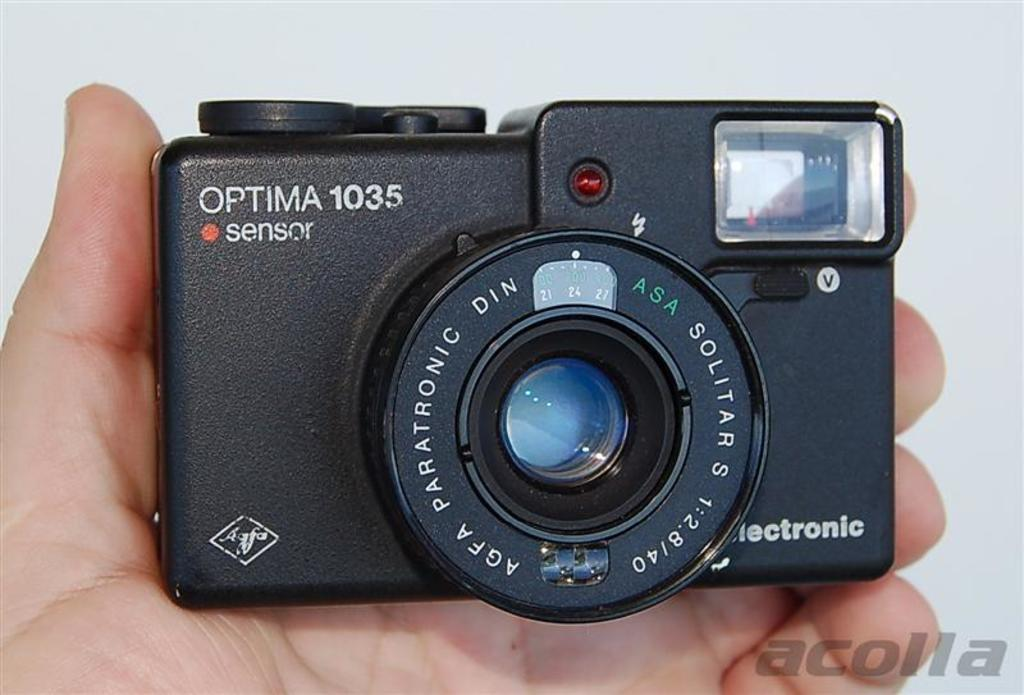What is the main subject of the image? There is a person in the image. What is the person holding in the image? The person is holding a camera. Can you describe any additional features of the image? There is a watermark on the image. What type of skin condition can be seen on the person's face in the image? There is no skin condition visible on the person's face in the image. What kind of shock can be felt by looking at the image? The image does not depict anything shocking, so no such feeling can be experienced. 